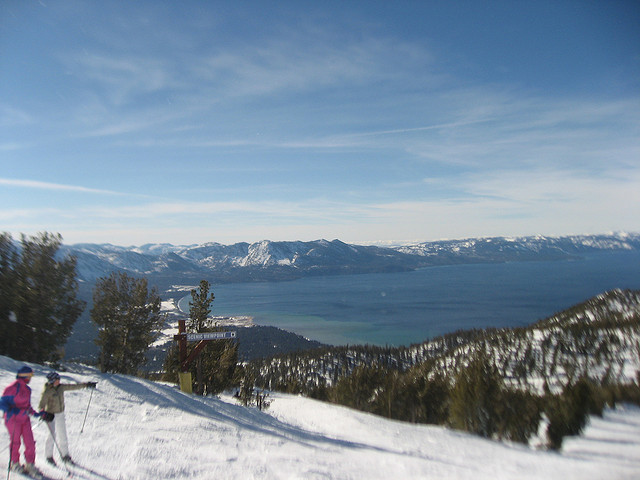<image>What type of clouds are here? I don't know what type of clouds are there. It can be thin, stratus, cirrus, cumulus or no cloud at all. What type of clouds are here? I am not sure what type of clouds are here. It can be seen thin, stratus, cirrus or cumulus clouds. 